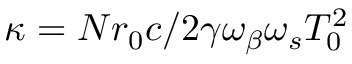Convert formula to latex. <formula><loc_0><loc_0><loc_500><loc_500>\kappa = N r _ { 0 } c / 2 \gamma \omega _ { \beta } \omega _ { s } T _ { 0 } ^ { 2 }</formula> 